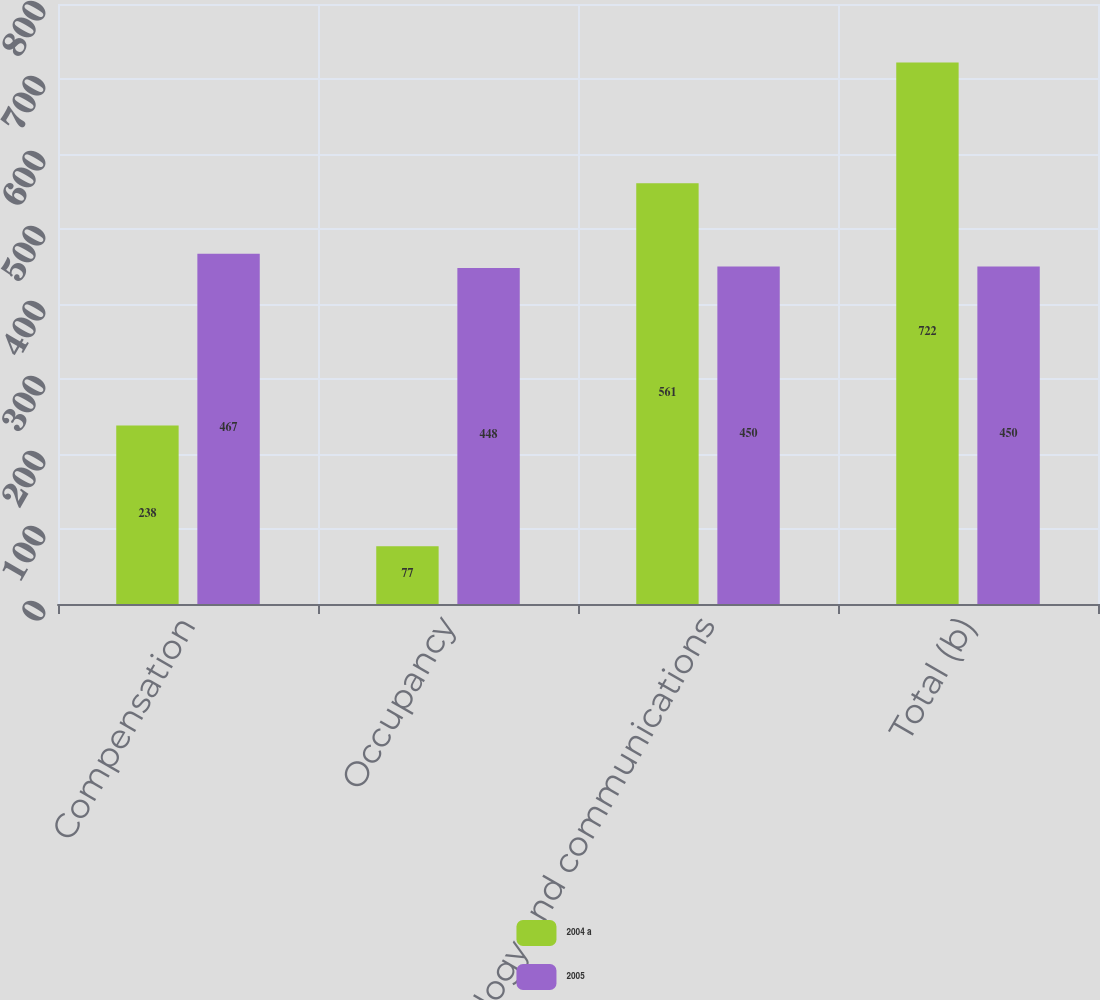<chart> <loc_0><loc_0><loc_500><loc_500><stacked_bar_chart><ecel><fcel>Compensation<fcel>Occupancy<fcel>Technology and communications<fcel>Total (b)<nl><fcel>2004 a<fcel>238<fcel>77<fcel>561<fcel>722<nl><fcel>2005<fcel>467<fcel>448<fcel>450<fcel>450<nl></chart> 